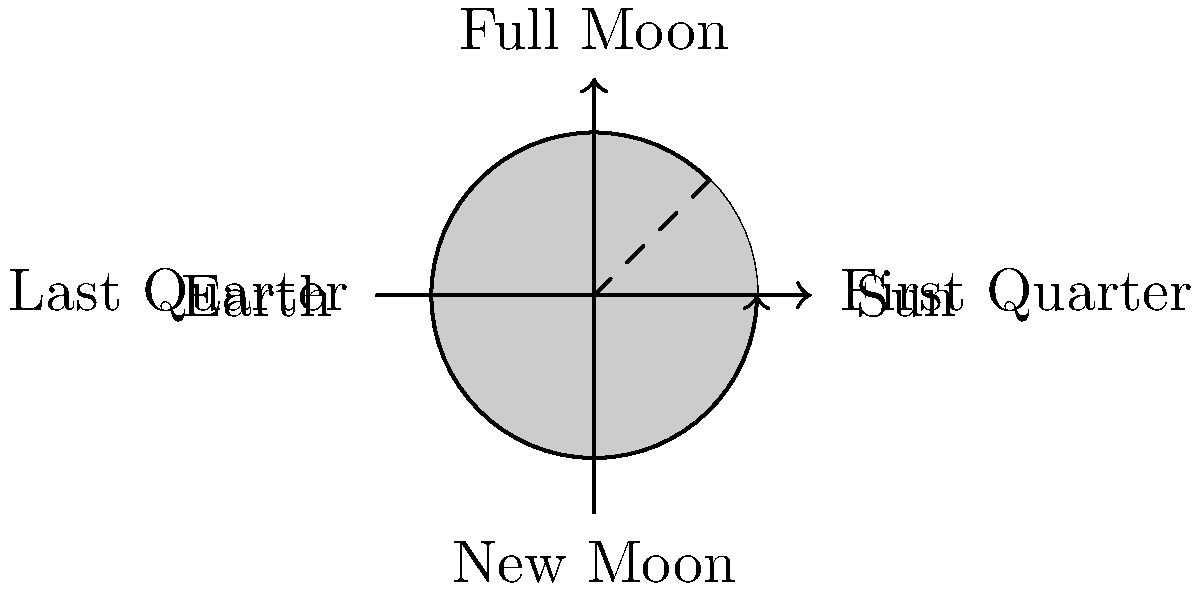As the athletics director, you're planning a night game for your team. How would you explain the visibility of the moon during its first quarter phase, and how might this affect the lighting conditions for the game? To understand the visibility of the moon during its first quarter phase and its impact on a night game, let's break it down step-by-step:

1. Moon phases: The moon's appearance changes based on its position relative to the Earth and Sun.

2. First quarter phase: This occurs when the moon has completed 1/4 of its orbit around Earth from the new moon position.

3. Illumination: During the first quarter, exactly half of the moon's visible surface is illuminated from Earth's perspective.

4. Shape: The moon appears as a "half-moon" with the right half illuminated (for observers in the Northern Hemisphere).

5. Visibility timing:
   a. Rises around noon
   b. Highest in the sky at sunset
   c. Sets around midnight

6. Lighting conditions for the game:
   a. If the game starts shortly after sunset, the first quarter moon will be high in the sky.
   b. It provides some natural illumination, but not as much as a full moon.
   c. The moon will set around midnight, so lighting conditions may change during a late game.

7. Impact on game planning:
   a. The first quarter moon offers moderate natural light in the early evening.
   b. Additional artificial lighting will still be necessary for optimal playing conditions.
   c. Be prepared for slightly darker conditions if the game extends past midnight.

Understanding these factors helps in planning appropriate lighting and scheduling for night games during the first quarter moon phase.
Answer: Half-illuminated, visible from noon to midnight, providing moderate evening light 